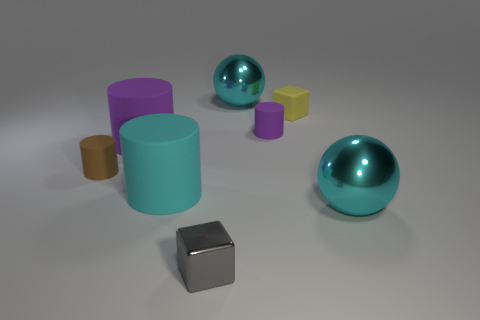Add 1 tiny metal cubes. How many objects exist? 9 Subtract all cubes. How many objects are left? 6 Add 3 metallic objects. How many metallic objects exist? 6 Subtract 1 brown cylinders. How many objects are left? 7 Subtract all small gray blocks. Subtract all yellow matte things. How many objects are left? 6 Add 8 large rubber things. How many large rubber things are left? 10 